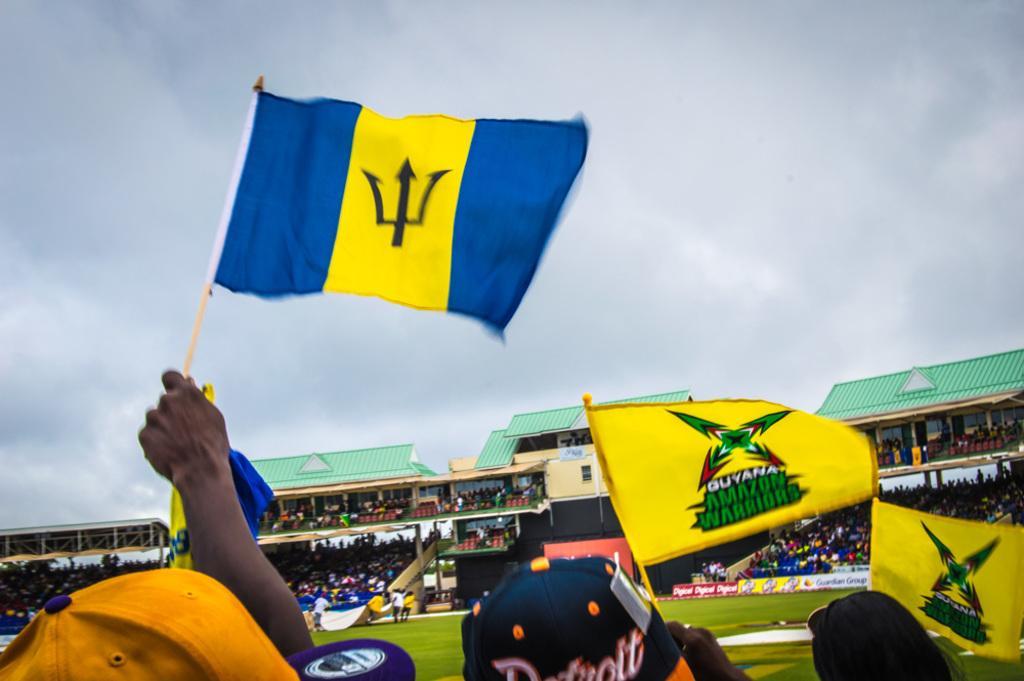Can you describe this image briefly? At the bottom of the image we can see persons holding a flags. In the background there are persons, grass, crowd, buildings, sky and clouds. 